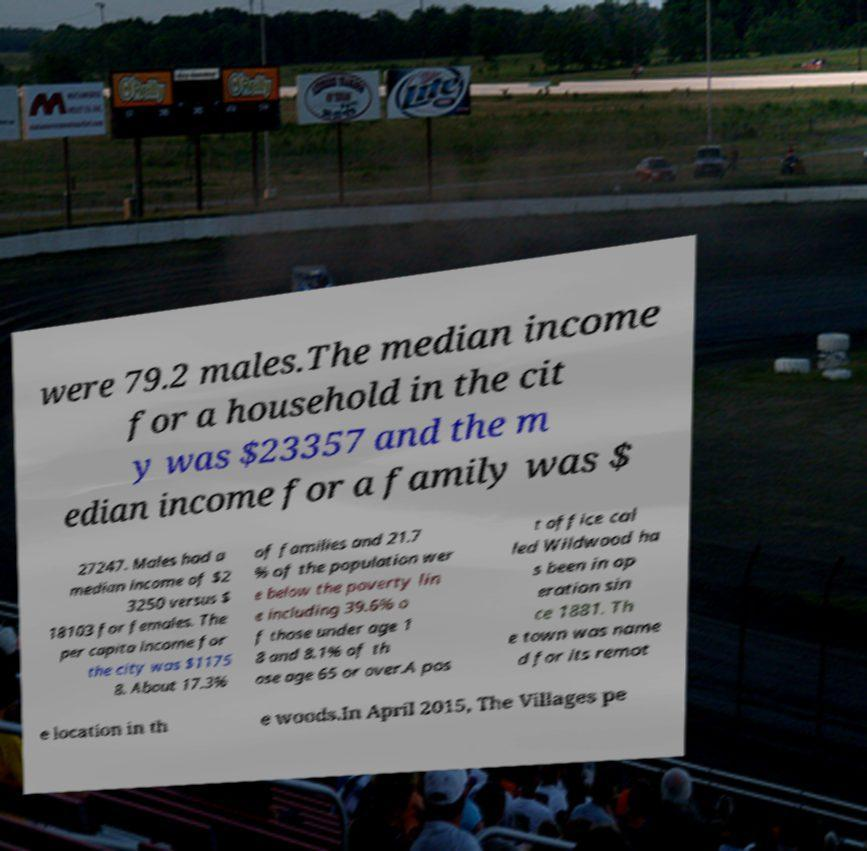There's text embedded in this image that I need extracted. Can you transcribe it verbatim? were 79.2 males.The median income for a household in the cit y was $23357 and the m edian income for a family was $ 27247. Males had a median income of $2 3250 versus $ 18103 for females. The per capita income for the city was $1175 8. About 17.3% of families and 21.7 % of the population wer e below the poverty lin e including 39.6% o f those under age 1 8 and 8.1% of th ose age 65 or over.A pos t office cal led Wildwood ha s been in op eration sin ce 1881. Th e town was name d for its remot e location in th e woods.In April 2015, The Villages pe 